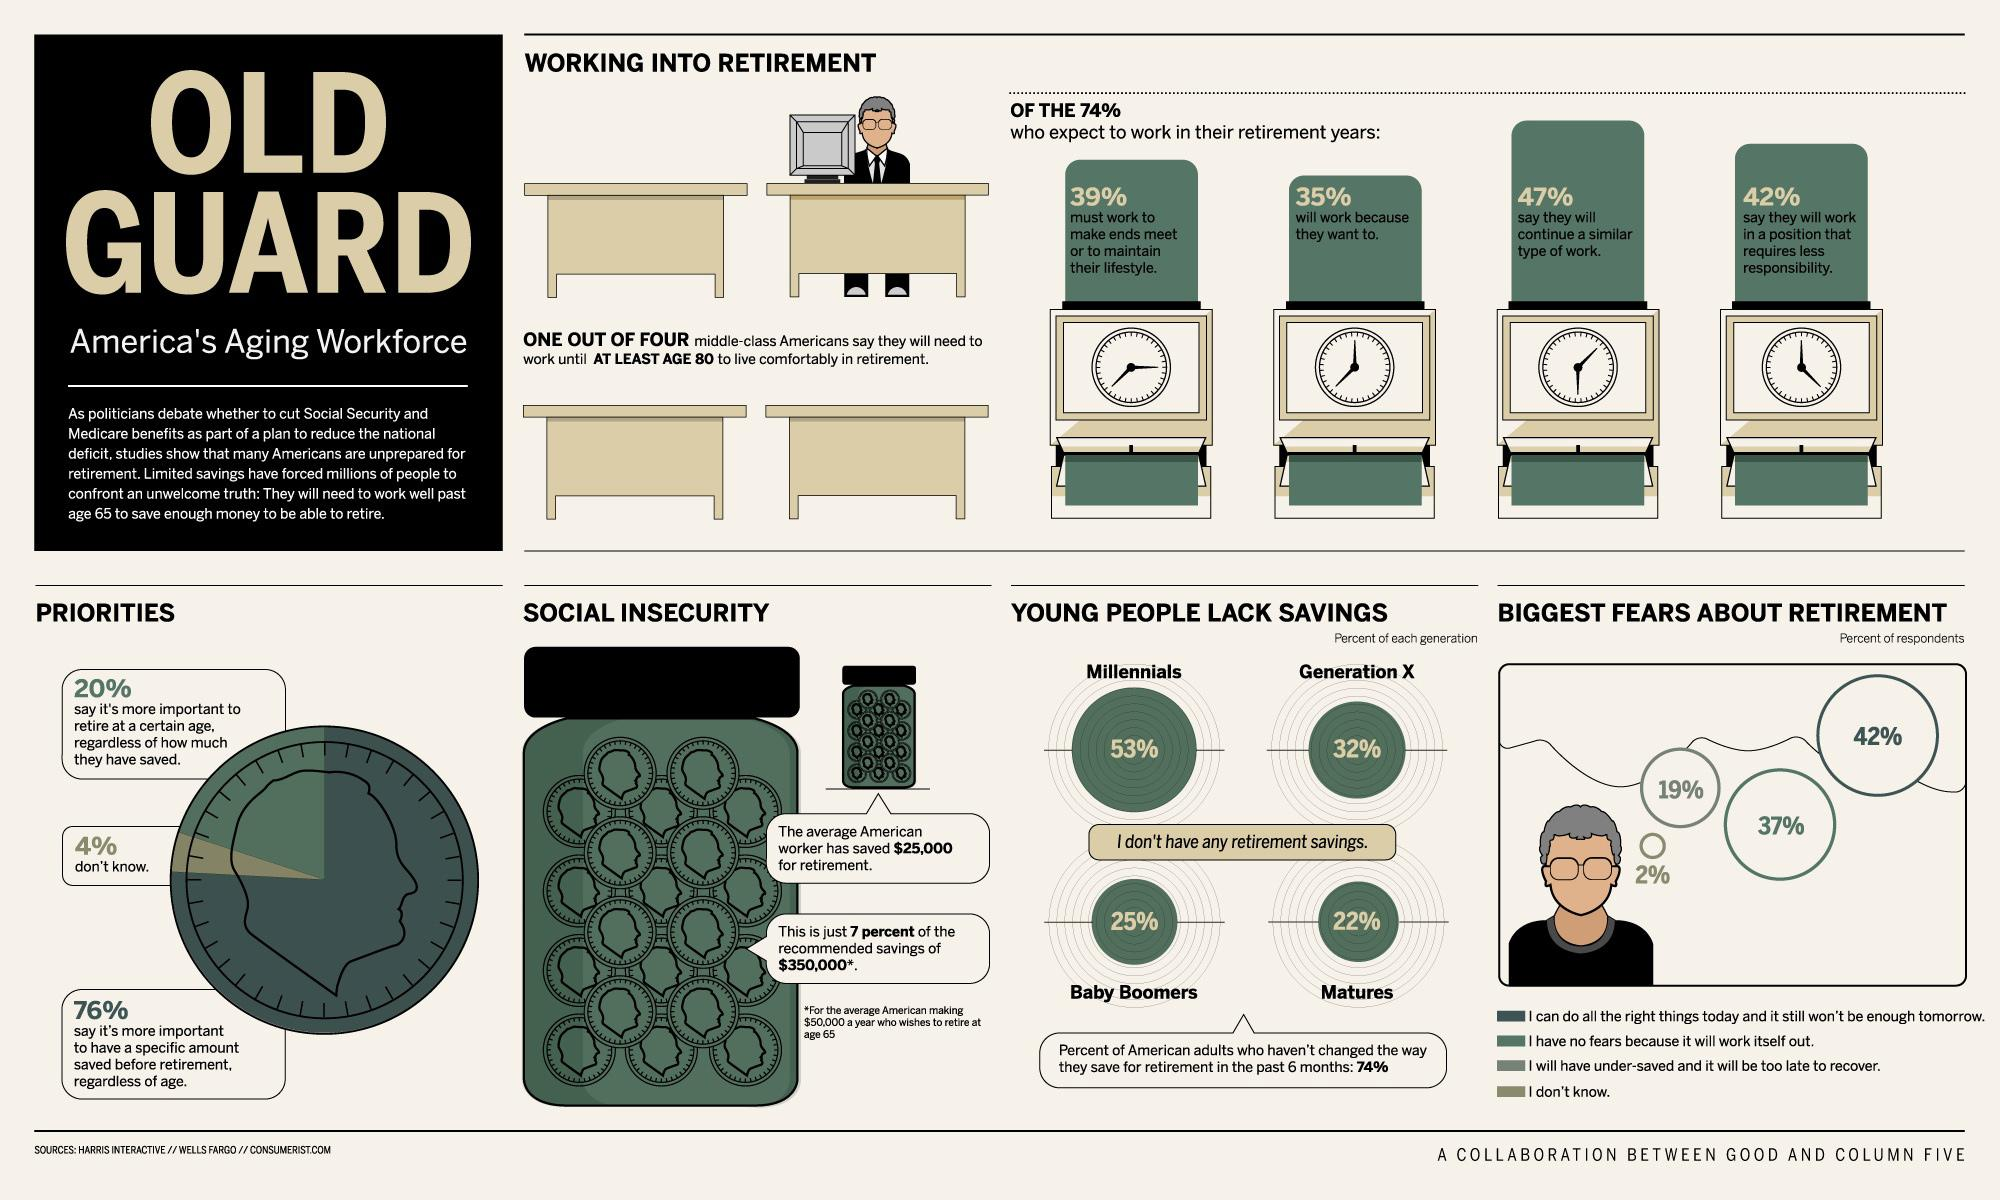Draw attention to some important aspects in this diagram. According to recent data, 25% of baby boomers in America do not have any retirement savings. According to a survey, 42% of Americans indicate that they plan to hold a job that carries less responsibility after they retire. According to a survey, 47% of Americans indicate that they will continue to work in a similar field after retirement. 